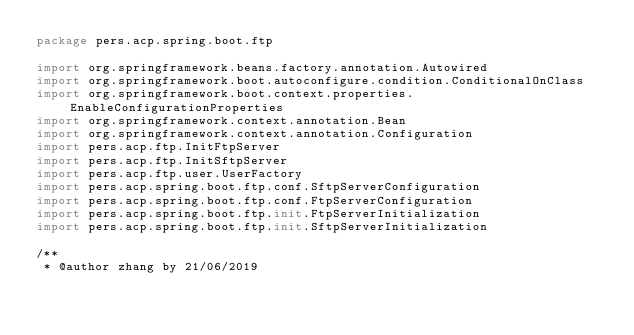Convert code to text. <code><loc_0><loc_0><loc_500><loc_500><_Kotlin_>package pers.acp.spring.boot.ftp

import org.springframework.beans.factory.annotation.Autowired
import org.springframework.boot.autoconfigure.condition.ConditionalOnClass
import org.springframework.boot.context.properties.EnableConfigurationProperties
import org.springframework.context.annotation.Bean
import org.springframework.context.annotation.Configuration
import pers.acp.ftp.InitFtpServer
import pers.acp.ftp.InitSftpServer
import pers.acp.ftp.user.UserFactory
import pers.acp.spring.boot.ftp.conf.SftpServerConfiguration
import pers.acp.spring.boot.ftp.conf.FtpServerConfiguration
import pers.acp.spring.boot.ftp.init.FtpServerInitialization
import pers.acp.spring.boot.ftp.init.SftpServerInitialization

/**
 * @author zhang by 21/06/2019</code> 